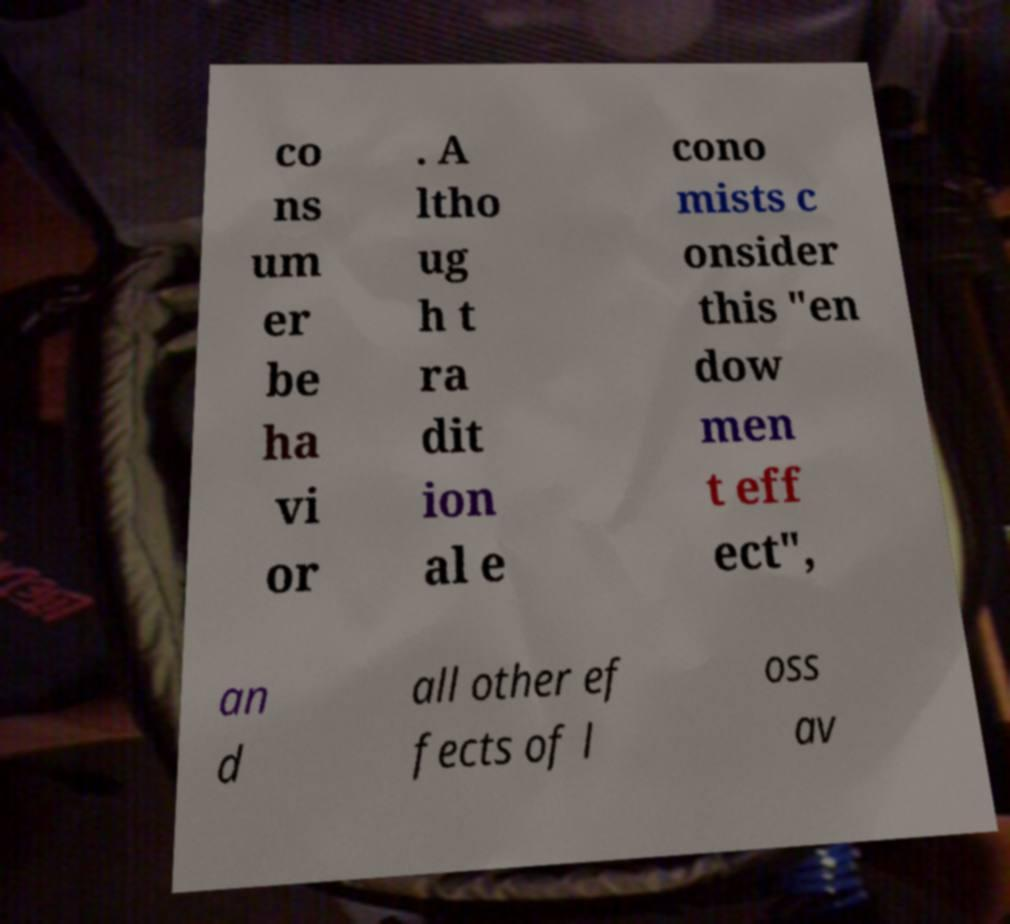There's text embedded in this image that I need extracted. Can you transcribe it verbatim? co ns um er be ha vi or . A ltho ug h t ra dit ion al e cono mists c onsider this "en dow men t eff ect", an d all other ef fects of l oss av 